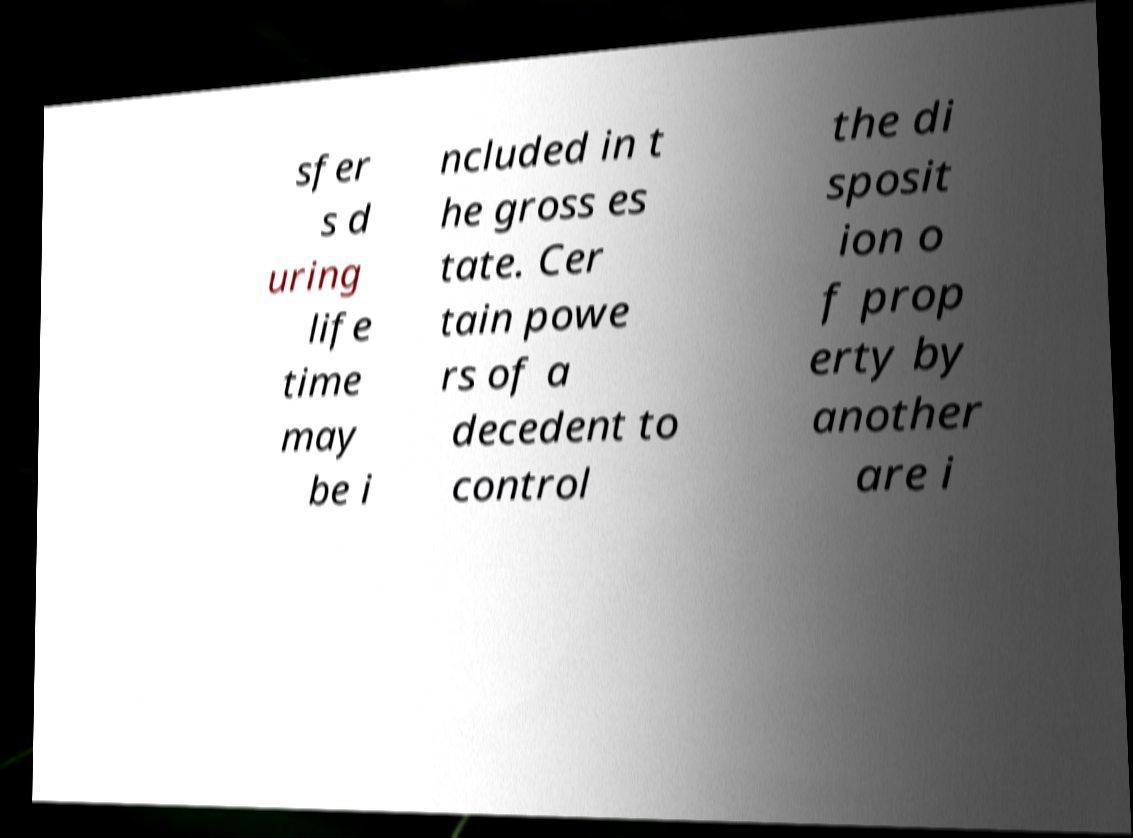Can you read and provide the text displayed in the image?This photo seems to have some interesting text. Can you extract and type it out for me? sfer s d uring life time may be i ncluded in t he gross es tate. Cer tain powe rs of a decedent to control the di sposit ion o f prop erty by another are i 